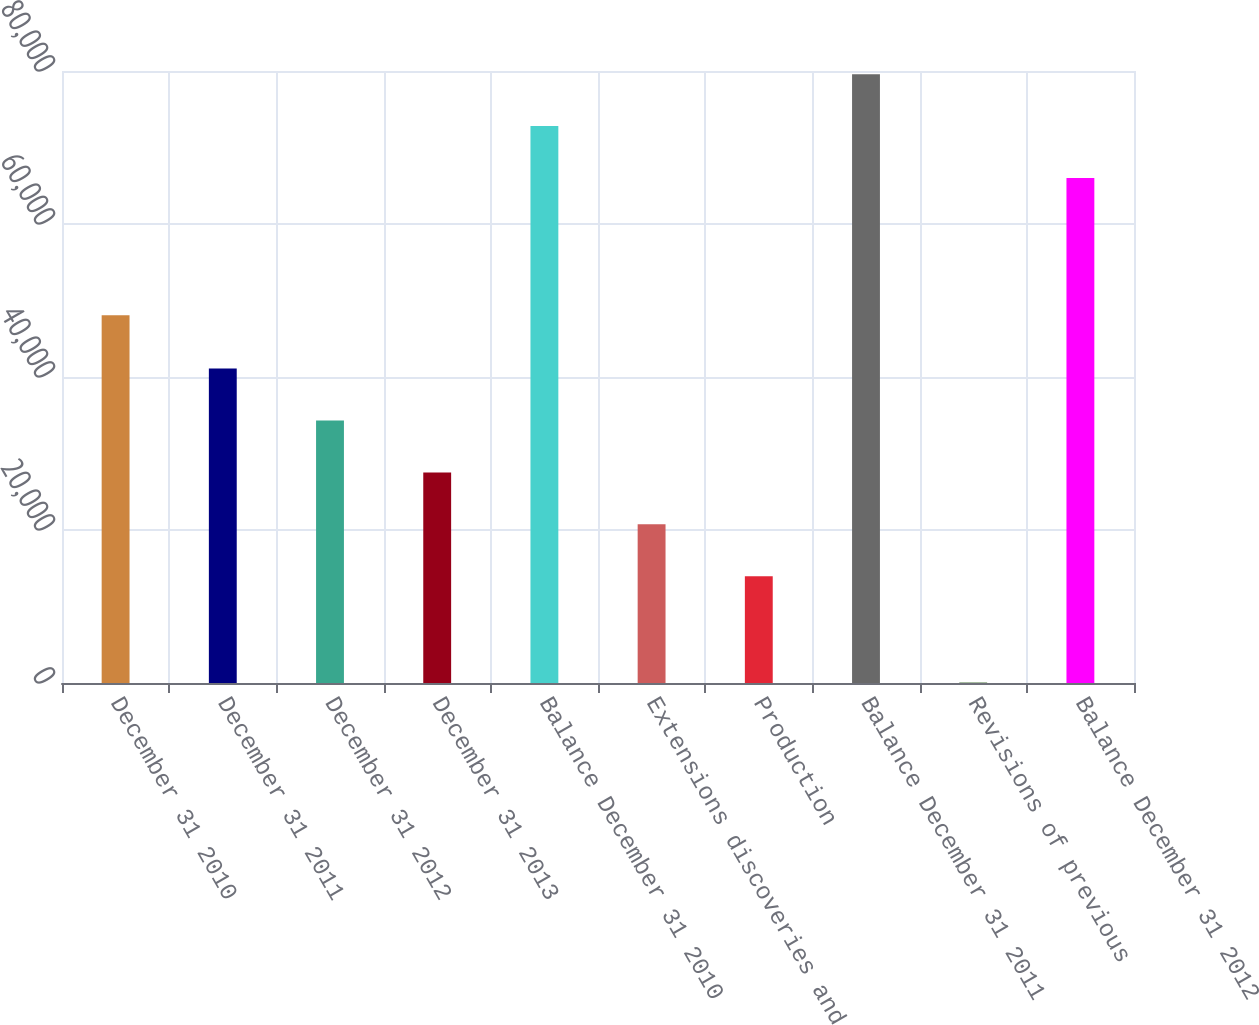Convert chart to OTSL. <chart><loc_0><loc_0><loc_500><loc_500><bar_chart><fcel>December 31 2010<fcel>December 31 2011<fcel>December 31 2012<fcel>December 31 2013<fcel>Balance December 31 2010<fcel>Extensions discoveries and<fcel>Production<fcel>Balance December 31 2011<fcel>Revisions of previous<fcel>Balance December 31 2012<nl><fcel>48072<fcel>41104.6<fcel>34316.7<fcel>27528.8<fcel>72802.8<fcel>20740.9<fcel>13953<fcel>79590.7<fcel>66<fcel>66014.9<nl></chart> 